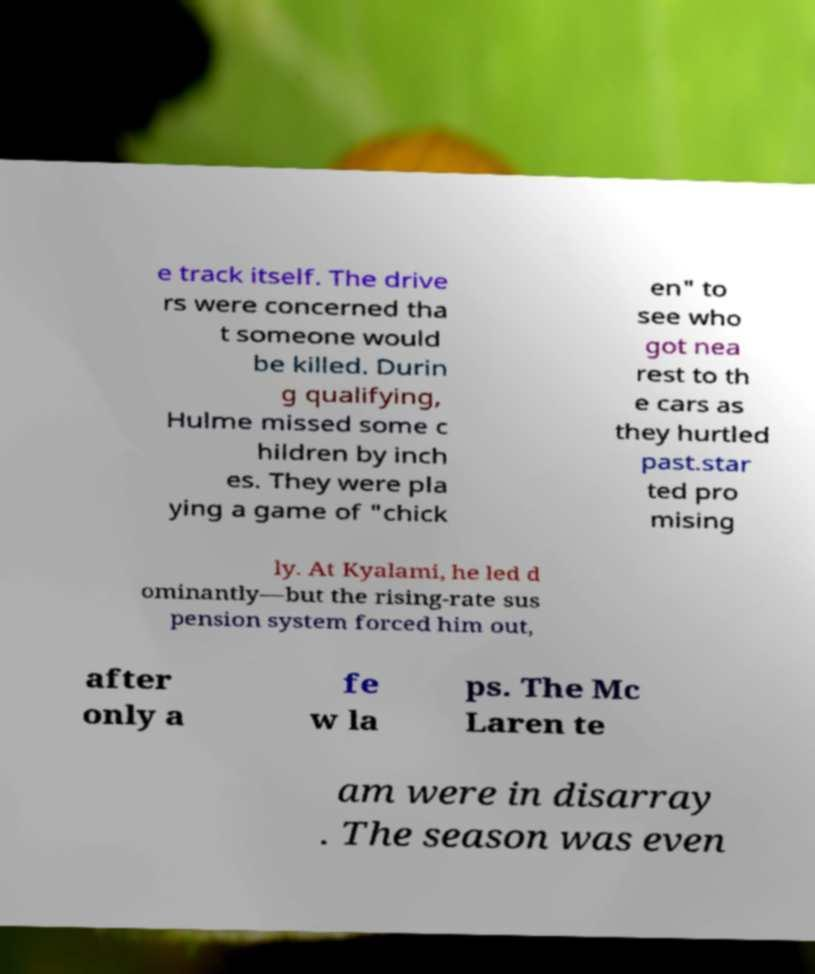Please read and relay the text visible in this image. What does it say? e track itself. The drive rs were concerned tha t someone would be killed. Durin g qualifying, Hulme missed some c hildren by inch es. They were pla ying a game of "chick en" to see who got nea rest to th e cars as they hurtled past.star ted pro mising ly. At Kyalami, he led d ominantly—but the rising-rate sus pension system forced him out, after only a fe w la ps. The Mc Laren te am were in disarray . The season was even 